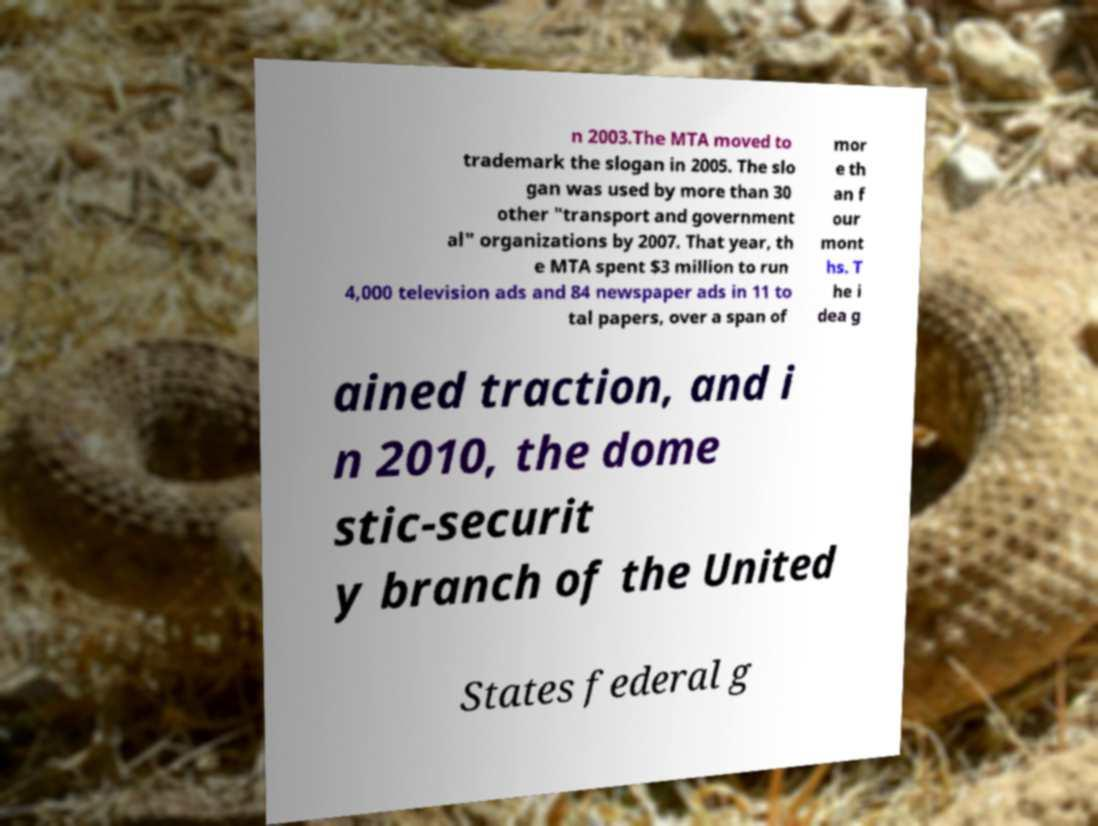Please read and relay the text visible in this image. What does it say? n 2003.The MTA moved to trademark the slogan in 2005. The slo gan was used by more than 30 other "transport and government al" organizations by 2007. That year, th e MTA spent $3 million to run 4,000 television ads and 84 newspaper ads in 11 to tal papers, over a span of mor e th an f our mont hs. T he i dea g ained traction, and i n 2010, the dome stic-securit y branch of the United States federal g 